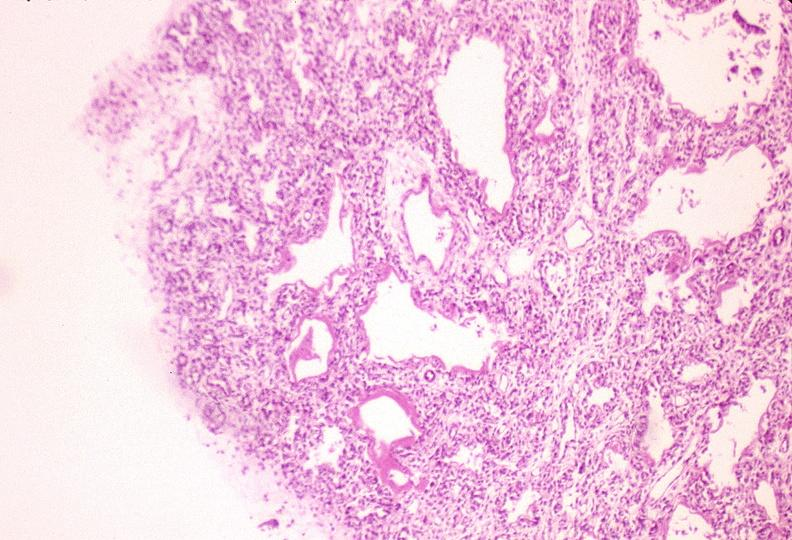s basal skull fracture present?
Answer the question using a single word or phrase. No 